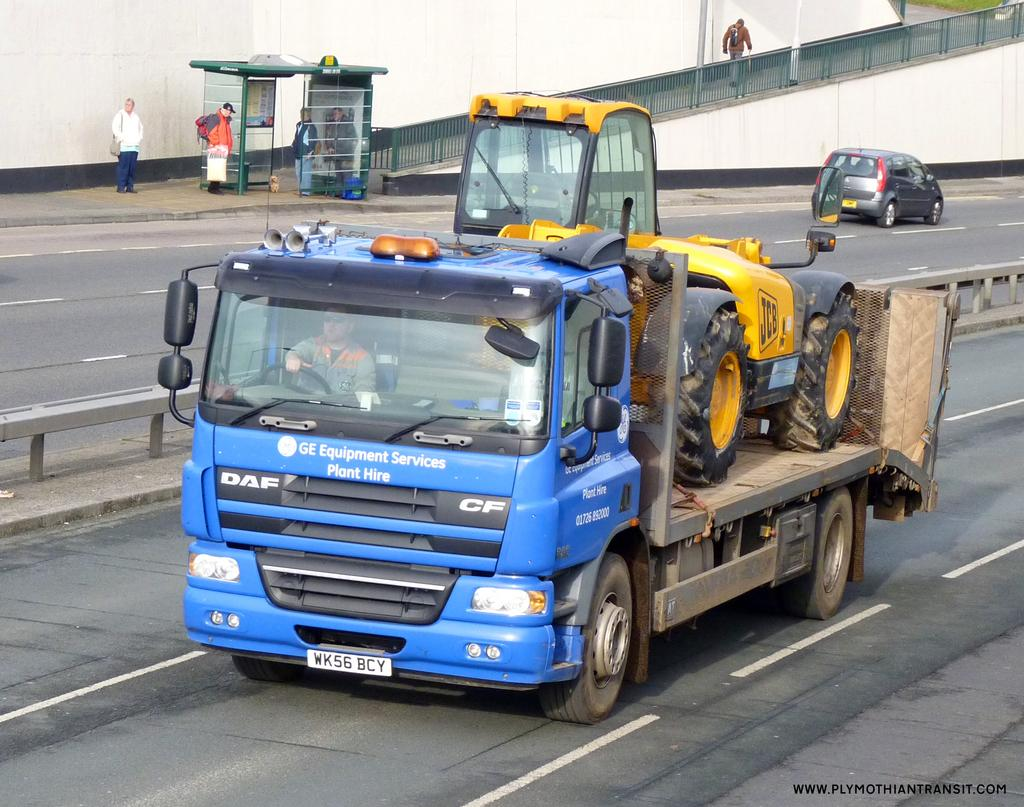What can be seen on the road in the image? There are vehicles on the road in the image. Are there any living beings visible in the image? Yes, there are people visible in the image. What type of barrier can be seen in the image? There is a fence in the image. What is visible in the background of the image? There is a wall in the background of the image. What type of insect can be seen crawling on the wall in the image? There is no insect visible on the wall in the image. What type of loss is being experienced by the people in the image? There is no indication of any loss being experienced by the people in the image. 